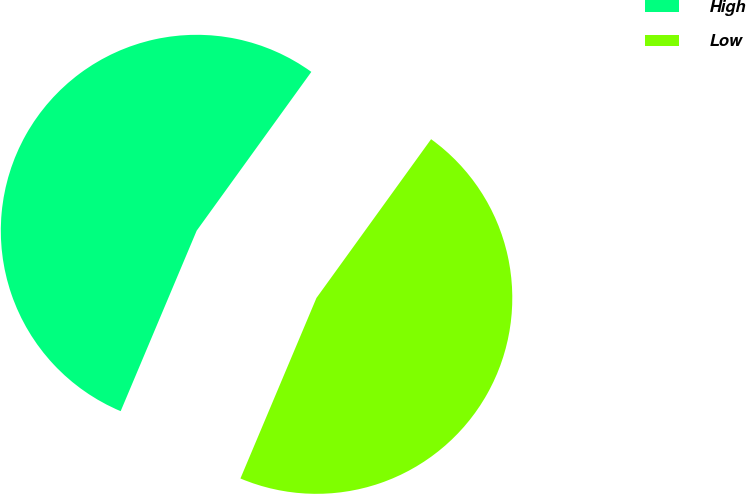Convert chart. <chart><loc_0><loc_0><loc_500><loc_500><pie_chart><fcel>High<fcel>Low<nl><fcel>53.61%<fcel>46.39%<nl></chart> 